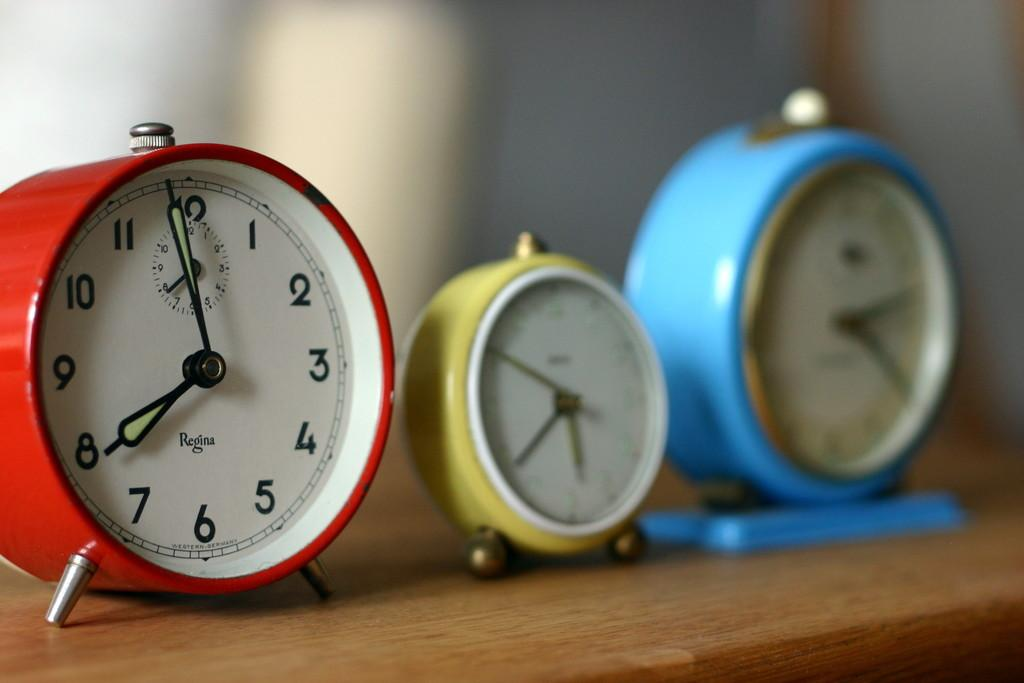Provide a one-sentence caption for the provided image. Three colorful analog clocks where the red one is made by Regina and set to 8:00. 